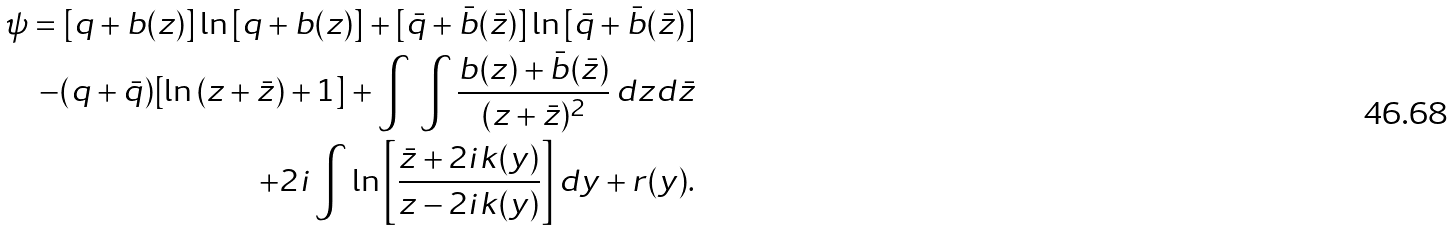Convert formula to latex. <formula><loc_0><loc_0><loc_500><loc_500>\psi = [ q + b ( z ) ] \ln { [ q + b ( z ) ] } + [ \bar { q } + \bar { b } ( \bar { z } ) ] \ln { [ \bar { q } + \bar { b } ( \bar { z } ) ] } \\ - ( q + \bar { q } ) [ \ln { ( z + \bar { z } ) } + 1 ] + \int \, \int \frac { b ( z ) + \bar { b } ( \bar { z } ) } { ( z + \bar { z } ) ^ { 2 } } \, d z d \bar { z } \\ + 2 i \int \ln { \left [ \frac { \bar { z } + 2 i k ( y ) } { z - 2 i k ( y ) } \right ] } \, d y + r ( y ) .</formula> 